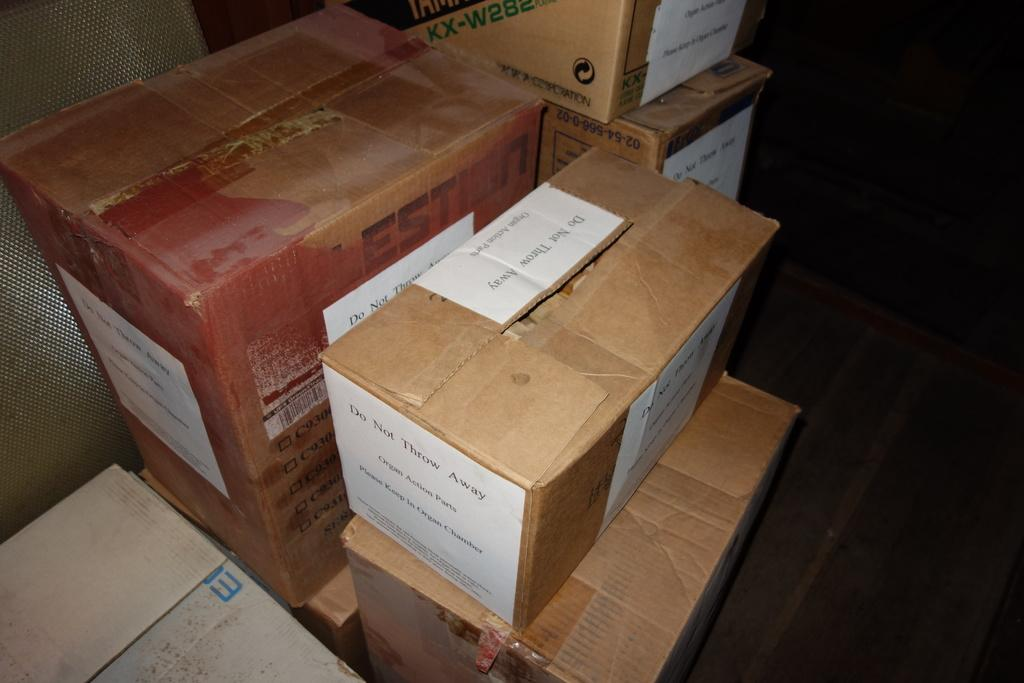<image>
Offer a succinct explanation of the picture presented. A box has a white piece of paper on it that is labeled organ action parts. 